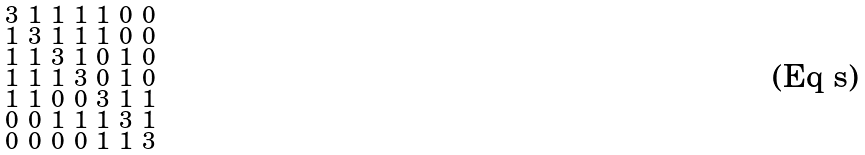Convert formula to latex. <formula><loc_0><loc_0><loc_500><loc_500>\begin{smallmatrix} 3 & 1 & 1 & 1 & 1 & 0 & 0 \\ 1 & 3 & 1 & 1 & 1 & 0 & 0 \\ 1 & 1 & 3 & 1 & 0 & 1 & 0 \\ 1 & 1 & 1 & 3 & 0 & 1 & 0 \\ 1 & 1 & 0 & 0 & 3 & 1 & 1 \\ 0 & 0 & 1 & 1 & 1 & 3 & 1 \\ 0 & 0 & 0 & 0 & 1 & 1 & 3 \end{smallmatrix}</formula> 